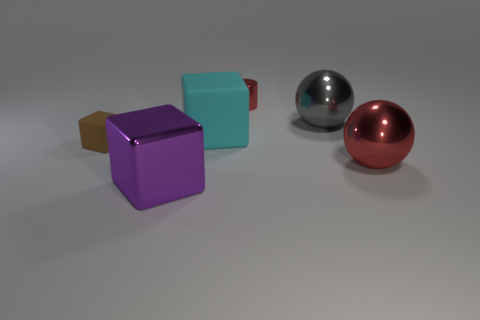Add 3 small matte objects. How many objects exist? 9 Subtract all red balls. How many balls are left? 1 Subtract all large matte blocks. How many blocks are left? 2 Subtract 0 yellow cylinders. How many objects are left? 6 Subtract all spheres. How many objects are left? 4 Subtract 1 balls. How many balls are left? 1 Subtract all brown spheres. Subtract all cyan cylinders. How many spheres are left? 2 Subtract all brown cubes. How many gray cylinders are left? 0 Subtract all tiny brown metallic cubes. Subtract all red shiny cylinders. How many objects are left? 5 Add 3 large red things. How many large red things are left? 4 